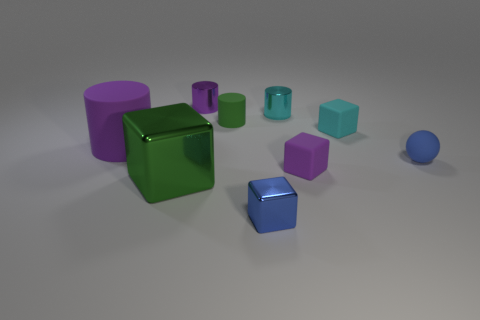Subtract all large green metal blocks. How many blocks are left? 3 Add 1 blue matte things. How many objects exist? 10 Subtract 3 cubes. How many cubes are left? 1 Subtract all yellow cubes. How many purple cylinders are left? 2 Subtract all green cylinders. How many cylinders are left? 3 Add 8 small blue balls. How many small blue balls exist? 9 Subtract 0 green balls. How many objects are left? 9 Subtract all blocks. How many objects are left? 5 Subtract all yellow balls. Subtract all blue cylinders. How many balls are left? 1 Subtract all large gray blocks. Subtract all cyan metallic cylinders. How many objects are left? 8 